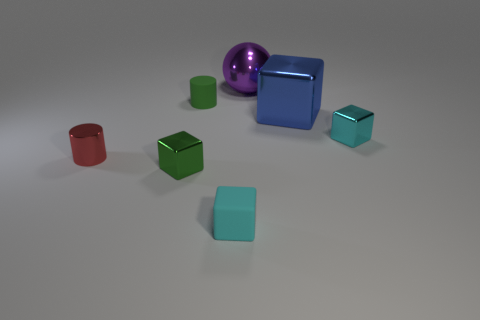Are there any repeating patterns or themes in the colors or shapes of the objects? Yes, there is a repetition in the shape of the objects where we can observe both cubes and cylinders repeated with different sizes and colors, suggesting a theme of geometric variations across the collection of objects. How does the variation in size impact the composition of the image? The variation in size creates a sense of depth and perspective, making the scene more dynamic and visually interesting. It also allows the viewer to compare the objects and understand their relationships in space more easily. 